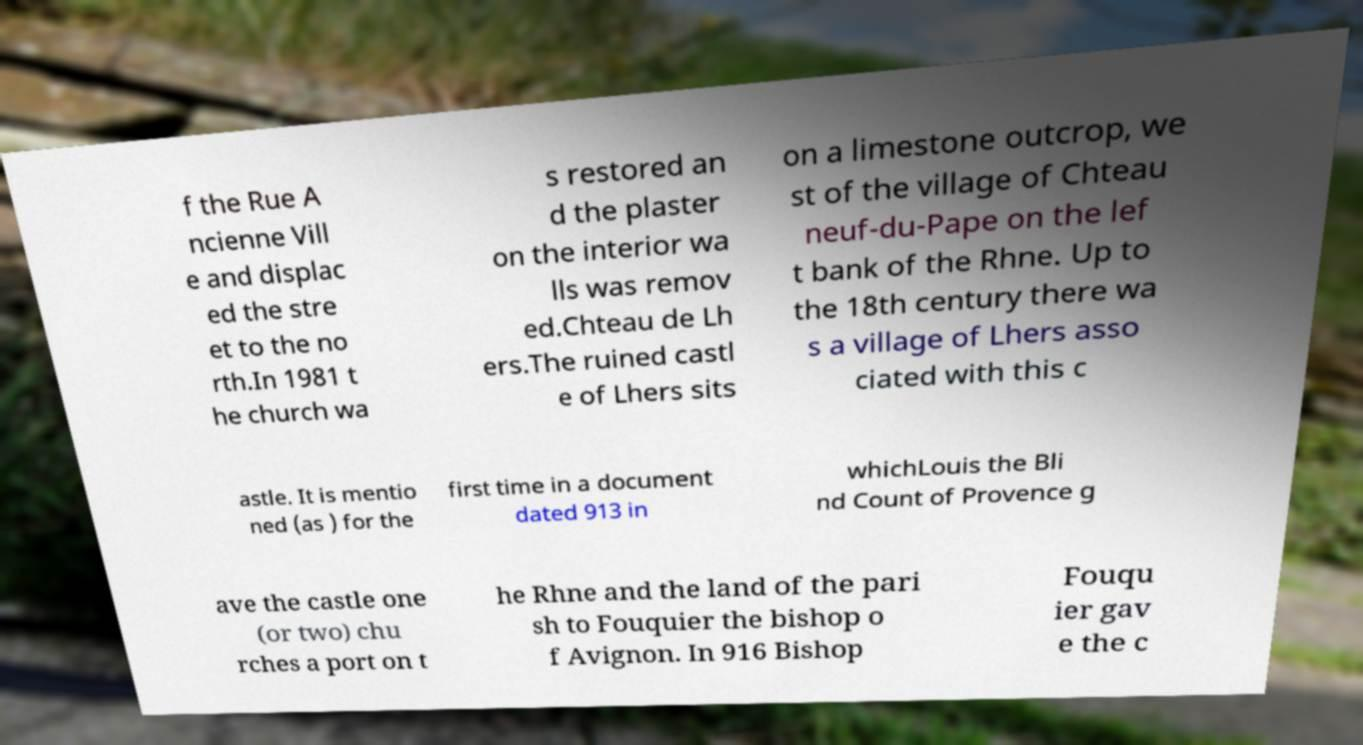There's text embedded in this image that I need extracted. Can you transcribe it verbatim? f the Rue A ncienne Vill e and displac ed the stre et to the no rth.In 1981 t he church wa s restored an d the plaster on the interior wa lls was remov ed.Chteau de Lh ers.The ruined castl e of Lhers sits on a limestone outcrop, we st of the village of Chteau neuf-du-Pape on the lef t bank of the Rhne. Up to the 18th century there wa s a village of Lhers asso ciated with this c astle. It is mentio ned (as ) for the first time in a document dated 913 in whichLouis the Bli nd Count of Provence g ave the castle one (or two) chu rches a port on t he Rhne and the land of the pari sh to Fouquier the bishop o f Avignon. In 916 Bishop Fouqu ier gav e the c 